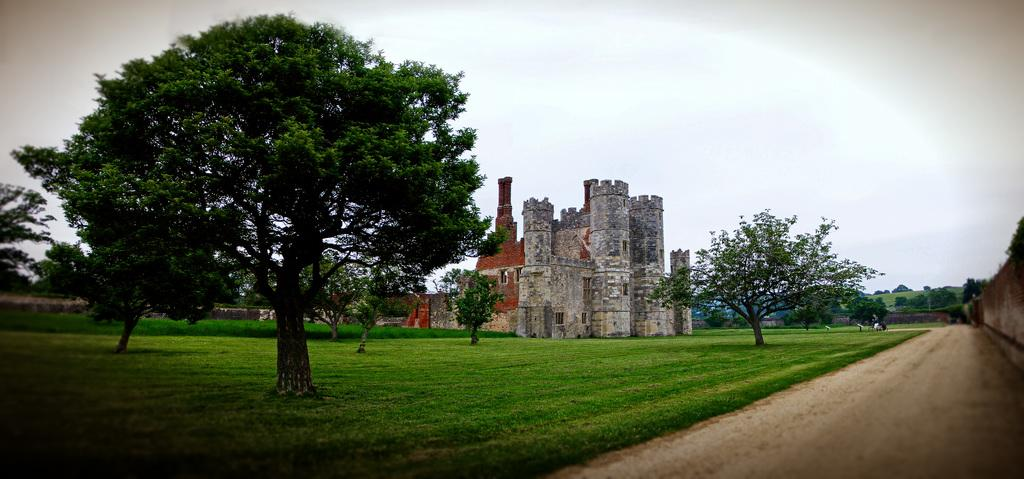What type of ground is visible in the image? There is grass ground in the image. What natural elements can be seen in the image? There are trees and the sky visible in the image. What man-made structure is present in the image? There is a building in the image. Can you describe the unspecified "few things" in the image? Unfortunately, the provided facts do not specify what these "few things" are, so we cannot describe them. What type of stick can be seen in the image? There is no stick present in the image. What is the journey of the sun in the image? The provided facts do not mention the sun or any journey, so we cannot answer this question. 